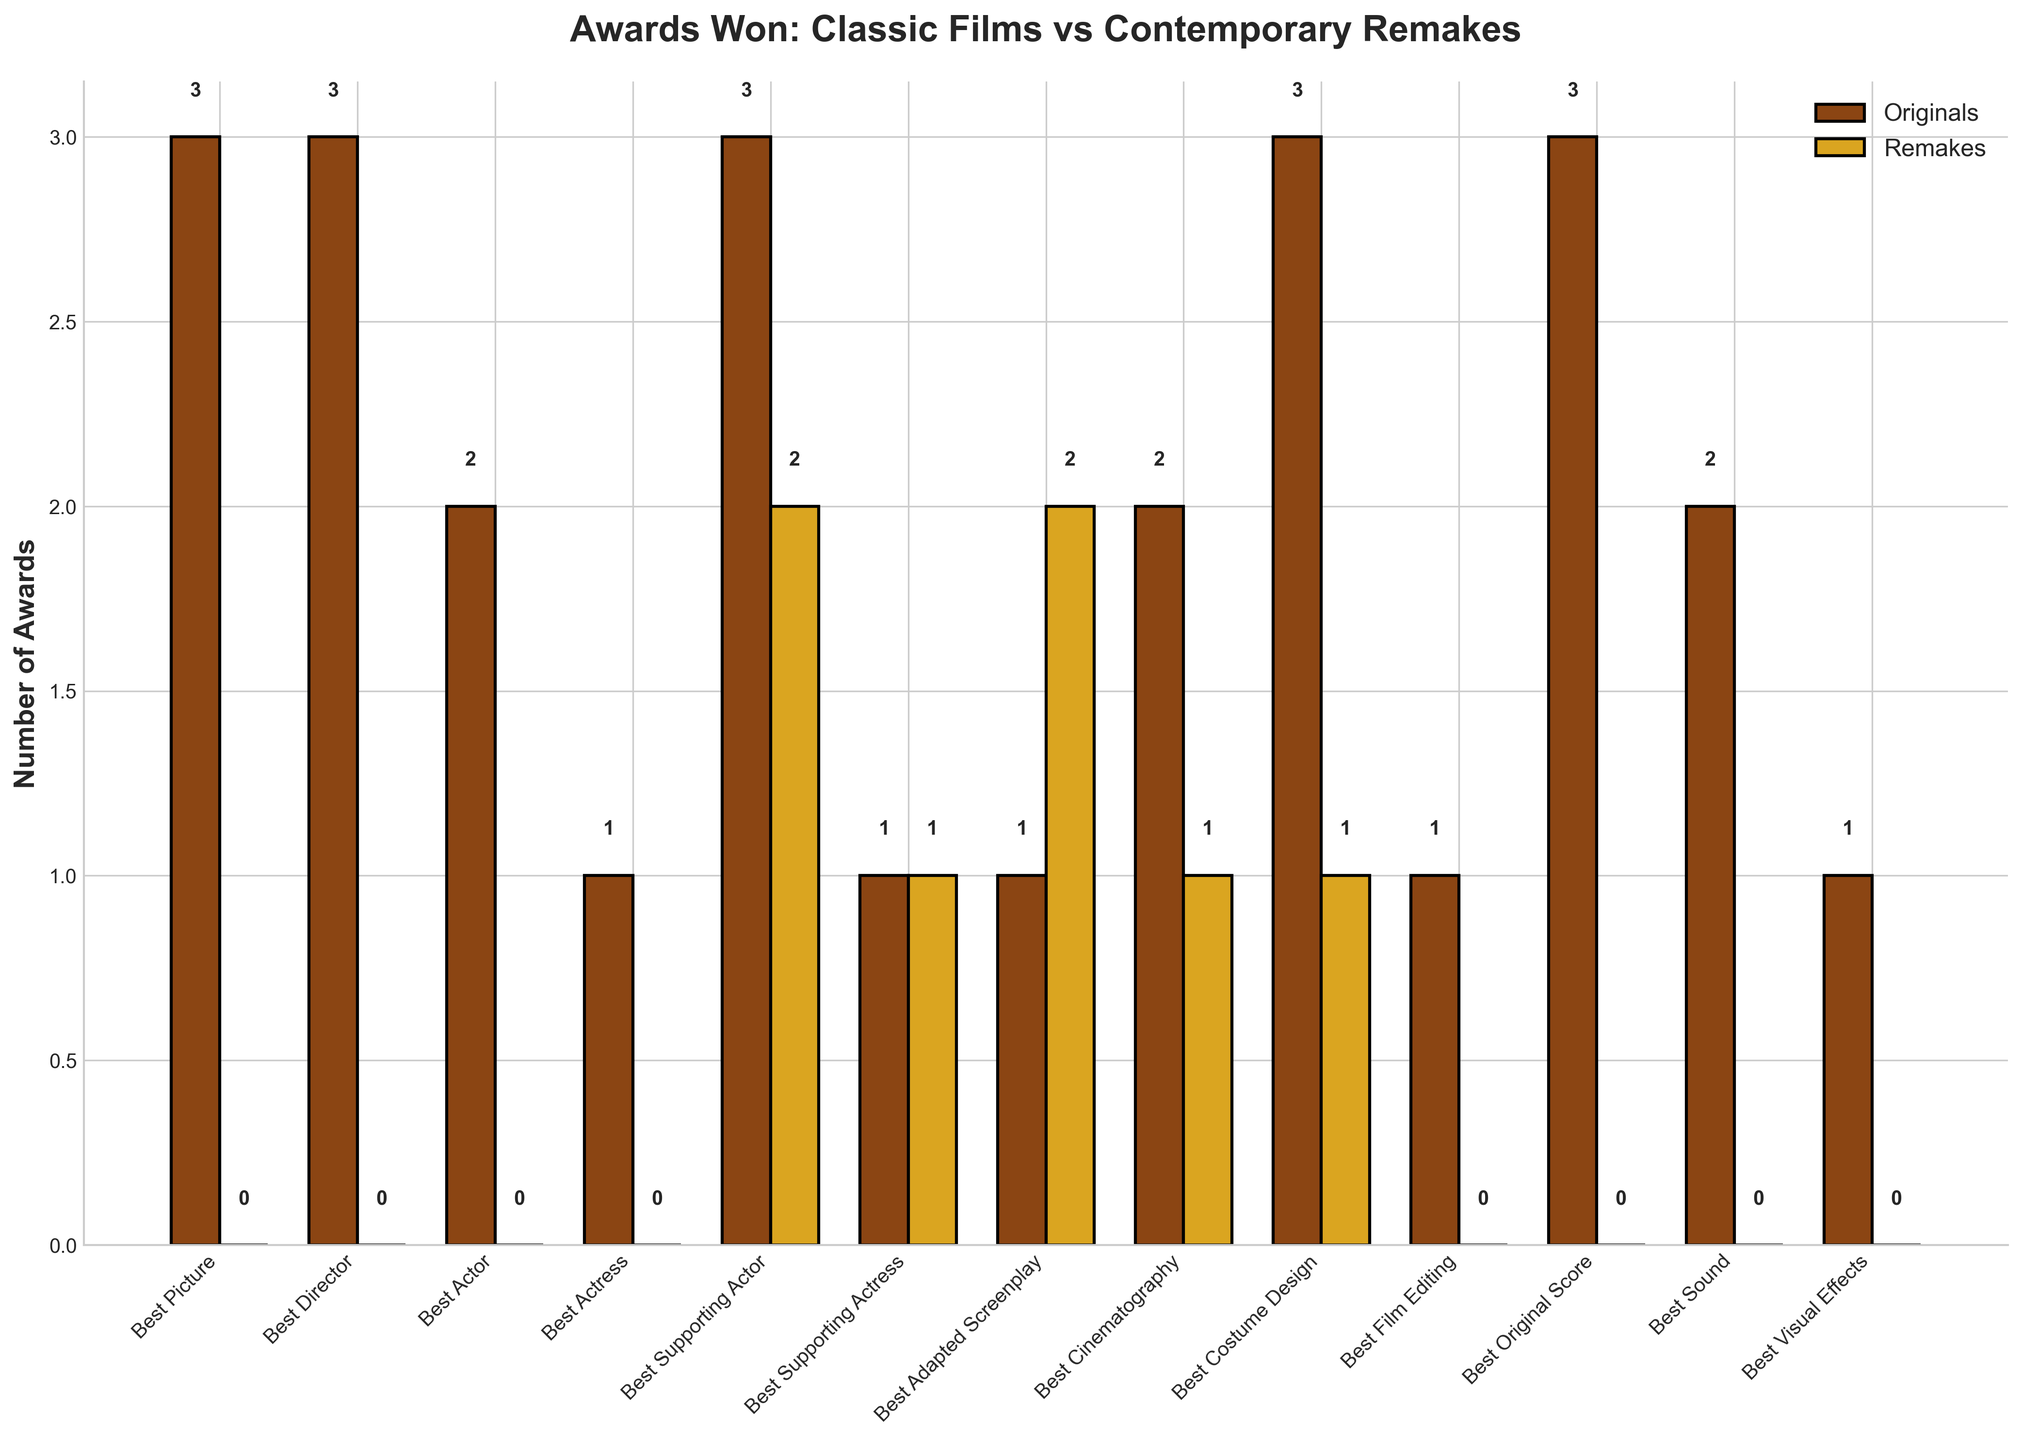Which category has the highest number of awards won by classic films? By looking at the heights of the bars representing classic films (shown in brown) in different categories, the "Best Actor," "Best Supporting Actor," and "Best Adapted Screenplay" categories have the highest bars, each with 4 awards.
Answer: Best Actor, Best Supporting Actor, Best Adapted Screenplay Did any contemporary remake win more awards than their original counterpart? By comparing the bars for each category, no contemporary remake wins more awards than their original counterpart across any category.
Answer: No How many total awards were won by contemporary remakes across all categories? Sum the values for all awards won by contemporary remakes, shown as gold bars, which are 0 + 0 + 0 + 0 + 4 + 1 + 3 + 2 + 2 + 0 + 0 + 0 + 0 = 12.
Answer: 12 Which category has a tie in the number of awards between classic and contemporary films? Look for categories where both brown and gold bars have the same height. "Best Supporting Actor" has equal awards for both classic and contemporary films, each with a total of 2.
Answer: Best Supporting Actor How many more awards do classic films have compared to contemporary remakes in the "Best Picture" category? The "Best Picture" category has 4 awards for classic films (brown bar) and 0 awards for contemporary remakes (gold bar), so the difference is 4 - 0 = 4.
Answer: 4 Which film from the remakes category has won the most awards and in which category? By examining the heights of the gold bars, "West Side Story (2021)" and "A Star Is Born (2018)" each have the highest single-category awards. "West Side Story (2021)" won two awards in "Best Supporting Actor" and "Best Adapted Screenplay," and "A Star Is Born (2018)" won in "Best Supporting Actor" and "Best Adapted Screenplay."
Answer: West Side Story (2021), Best Supporting Actor and Best Adapted Screenplay; A Star Is Born (2018), Best Supporting Actor and Best Adapted Screenplay Is the total number of awards equal for any film and its remake pair? Compare the total number of awards for each classic film and its remake pair by summing the relevant awards. No classic film and its remake have an equal total number of awards.
Answer: No Which category shows the greatest disparity in awards between classic films and contemporary remakes? Find the category with the maximum difference between the heights of the brown and gold bars. "Best Original Score" shows the greatest disparity with classic films having 4 awards and contemporary remakes having 0, resulting in a disparity of 4.
Answer: Best Original Score 